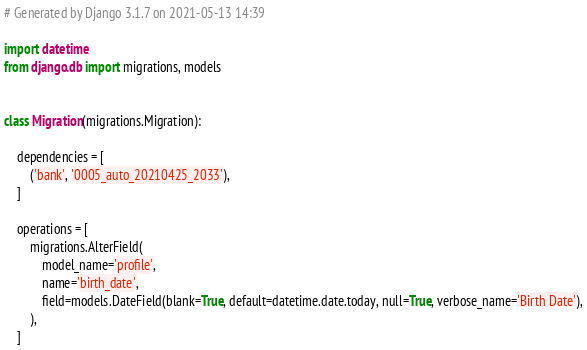Convert code to text. <code><loc_0><loc_0><loc_500><loc_500><_Python_># Generated by Django 3.1.7 on 2021-05-13 14:39

import datetime
from django.db import migrations, models


class Migration(migrations.Migration):

    dependencies = [
        ('bank', '0005_auto_20210425_2033'),
    ]

    operations = [
        migrations.AlterField(
            model_name='profile',
            name='birth_date',
            field=models.DateField(blank=True, default=datetime.date.today, null=True, verbose_name='Birth Date'),
        ),
    ]
</code> 